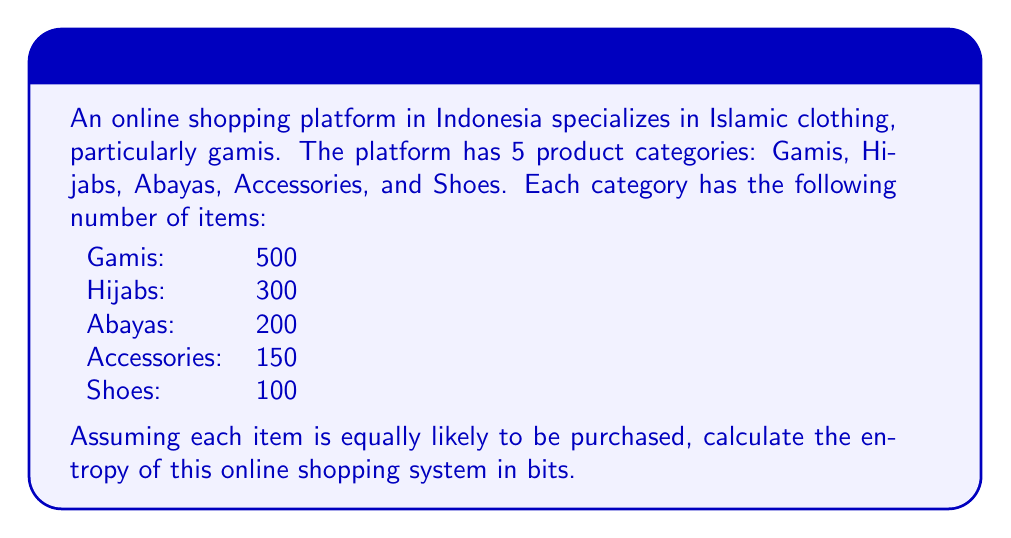Provide a solution to this math problem. To calculate the entropy of this online shopping system, we'll follow these steps:

1. Calculate the total number of items:
   $N_{total} = 500 + 300 + 200 + 150 + 100 = 1250$

2. Calculate the probability of selecting an item from each category:
   $p_{Gamis} = 500/1250 = 0.4$
   $p_{Hijabs} = 300/1250 = 0.24$
   $p_{Abayas} = 200/1250 = 0.16$
   $p_{Accessories} = 150/1250 = 0.12$
   $p_{Shoes} = 100/1250 = 0.08$

3. Use the entropy formula:
   $$S = -k \sum_{i} p_i \log_2(p_i)$$
   where $k = 1$ (as we're calculating in bits) and $i$ represents each category.

4. Substitute the probabilities into the formula:
   $$\begin{align}
   S &= -[0.4 \log_2(0.4) + 0.24 \log_2(0.24) + 0.16 \log_2(0.16) \\
   &\quad + 0.12 \log_2(0.12) + 0.08 \log_2(0.08)]
   \end{align}$$

5. Calculate each term:
   $0.4 \log_2(0.4) \approx -0.5288$
   $0.24 \log_2(0.24) \approx -0.4949$
   $0.16 \log_2(0.16) \approx -0.4308$
   $0.12 \log_2(0.12) \approx -0.3672$
   $0.08 \log_2(0.08) \approx -0.2915$

6. Sum up the terms and take the negative:
   $$S = -(-0.5288 - 0.4949 - 0.4308 - 0.3672 - 0.2915) \approx 2.1132$$

Therefore, the entropy of this online shopping system is approximately 2.1132 bits.
Answer: 2.1132 bits 